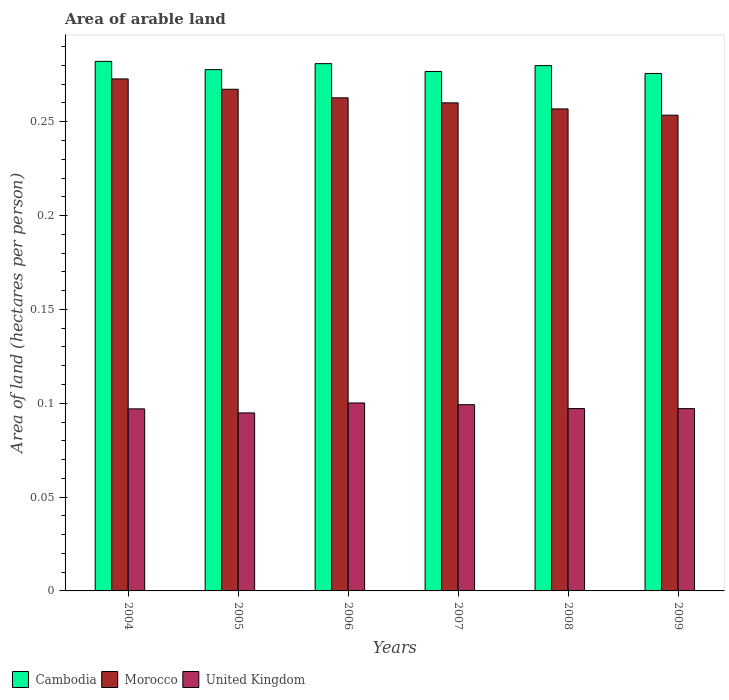How many groups of bars are there?
Provide a short and direct response. 6. Are the number of bars on each tick of the X-axis equal?
Offer a very short reply. Yes. How many bars are there on the 5th tick from the right?
Make the answer very short. 3. In how many cases, is the number of bars for a given year not equal to the number of legend labels?
Offer a very short reply. 0. What is the total arable land in Morocco in 2005?
Provide a short and direct response. 0.27. Across all years, what is the maximum total arable land in United Kingdom?
Keep it short and to the point. 0.1. Across all years, what is the minimum total arable land in United Kingdom?
Provide a short and direct response. 0.09. In which year was the total arable land in Cambodia maximum?
Your response must be concise. 2004. What is the total total arable land in Morocco in the graph?
Provide a succinct answer. 1.57. What is the difference between the total arable land in Morocco in 2008 and that in 2009?
Provide a short and direct response. 0. What is the difference between the total arable land in Cambodia in 2009 and the total arable land in United Kingdom in 2006?
Provide a short and direct response. 0.18. What is the average total arable land in United Kingdom per year?
Make the answer very short. 0.1. In the year 2007, what is the difference between the total arable land in United Kingdom and total arable land in Cambodia?
Your response must be concise. -0.18. What is the ratio of the total arable land in United Kingdom in 2008 to that in 2009?
Your answer should be compact. 1. Is the difference between the total arable land in United Kingdom in 2006 and 2007 greater than the difference between the total arable land in Cambodia in 2006 and 2007?
Provide a succinct answer. No. What is the difference between the highest and the second highest total arable land in Cambodia?
Provide a short and direct response. 0. What is the difference between the highest and the lowest total arable land in United Kingdom?
Your response must be concise. 0.01. In how many years, is the total arable land in Morocco greater than the average total arable land in Morocco taken over all years?
Provide a short and direct response. 3. What does the 1st bar from the left in 2008 represents?
Provide a succinct answer. Cambodia. What does the 3rd bar from the right in 2004 represents?
Make the answer very short. Cambodia. Is it the case that in every year, the sum of the total arable land in Morocco and total arable land in United Kingdom is greater than the total arable land in Cambodia?
Keep it short and to the point. Yes. Are the values on the major ticks of Y-axis written in scientific E-notation?
Ensure brevity in your answer.  No. Does the graph contain any zero values?
Make the answer very short. No. Does the graph contain grids?
Your answer should be compact. No. How many legend labels are there?
Provide a succinct answer. 3. What is the title of the graph?
Give a very brief answer. Area of arable land. Does "Malawi" appear as one of the legend labels in the graph?
Provide a succinct answer. No. What is the label or title of the X-axis?
Give a very brief answer. Years. What is the label or title of the Y-axis?
Offer a very short reply. Area of land (hectares per person). What is the Area of land (hectares per person) of Cambodia in 2004?
Keep it short and to the point. 0.28. What is the Area of land (hectares per person) of Morocco in 2004?
Provide a short and direct response. 0.27. What is the Area of land (hectares per person) in United Kingdom in 2004?
Your response must be concise. 0.1. What is the Area of land (hectares per person) of Cambodia in 2005?
Offer a very short reply. 0.28. What is the Area of land (hectares per person) of Morocco in 2005?
Give a very brief answer. 0.27. What is the Area of land (hectares per person) in United Kingdom in 2005?
Ensure brevity in your answer.  0.09. What is the Area of land (hectares per person) of Cambodia in 2006?
Provide a short and direct response. 0.28. What is the Area of land (hectares per person) in Morocco in 2006?
Your answer should be compact. 0.26. What is the Area of land (hectares per person) in United Kingdom in 2006?
Ensure brevity in your answer.  0.1. What is the Area of land (hectares per person) of Cambodia in 2007?
Provide a short and direct response. 0.28. What is the Area of land (hectares per person) in Morocco in 2007?
Keep it short and to the point. 0.26. What is the Area of land (hectares per person) in United Kingdom in 2007?
Keep it short and to the point. 0.1. What is the Area of land (hectares per person) in Cambodia in 2008?
Provide a succinct answer. 0.28. What is the Area of land (hectares per person) in Morocco in 2008?
Offer a very short reply. 0.26. What is the Area of land (hectares per person) in United Kingdom in 2008?
Keep it short and to the point. 0.1. What is the Area of land (hectares per person) in Cambodia in 2009?
Offer a very short reply. 0.28. What is the Area of land (hectares per person) of Morocco in 2009?
Provide a succinct answer. 0.25. What is the Area of land (hectares per person) of United Kingdom in 2009?
Your answer should be compact. 0.1. Across all years, what is the maximum Area of land (hectares per person) in Cambodia?
Offer a very short reply. 0.28. Across all years, what is the maximum Area of land (hectares per person) of Morocco?
Offer a terse response. 0.27. Across all years, what is the maximum Area of land (hectares per person) of United Kingdom?
Ensure brevity in your answer.  0.1. Across all years, what is the minimum Area of land (hectares per person) in Cambodia?
Keep it short and to the point. 0.28. Across all years, what is the minimum Area of land (hectares per person) of Morocco?
Keep it short and to the point. 0.25. Across all years, what is the minimum Area of land (hectares per person) in United Kingdom?
Your response must be concise. 0.09. What is the total Area of land (hectares per person) of Cambodia in the graph?
Your response must be concise. 1.67. What is the total Area of land (hectares per person) of Morocco in the graph?
Keep it short and to the point. 1.57. What is the total Area of land (hectares per person) of United Kingdom in the graph?
Your answer should be compact. 0.59. What is the difference between the Area of land (hectares per person) of Cambodia in 2004 and that in 2005?
Make the answer very short. 0. What is the difference between the Area of land (hectares per person) of Morocco in 2004 and that in 2005?
Ensure brevity in your answer.  0.01. What is the difference between the Area of land (hectares per person) of United Kingdom in 2004 and that in 2005?
Give a very brief answer. 0. What is the difference between the Area of land (hectares per person) in Cambodia in 2004 and that in 2006?
Your answer should be very brief. 0. What is the difference between the Area of land (hectares per person) in Morocco in 2004 and that in 2006?
Provide a succinct answer. 0.01. What is the difference between the Area of land (hectares per person) of United Kingdom in 2004 and that in 2006?
Provide a short and direct response. -0. What is the difference between the Area of land (hectares per person) in Cambodia in 2004 and that in 2007?
Keep it short and to the point. 0.01. What is the difference between the Area of land (hectares per person) of Morocco in 2004 and that in 2007?
Your answer should be very brief. 0.01. What is the difference between the Area of land (hectares per person) in United Kingdom in 2004 and that in 2007?
Keep it short and to the point. -0. What is the difference between the Area of land (hectares per person) in Cambodia in 2004 and that in 2008?
Offer a very short reply. 0. What is the difference between the Area of land (hectares per person) of Morocco in 2004 and that in 2008?
Provide a succinct answer. 0.02. What is the difference between the Area of land (hectares per person) of United Kingdom in 2004 and that in 2008?
Ensure brevity in your answer.  -0. What is the difference between the Area of land (hectares per person) in Cambodia in 2004 and that in 2009?
Keep it short and to the point. 0.01. What is the difference between the Area of land (hectares per person) in Morocco in 2004 and that in 2009?
Keep it short and to the point. 0.02. What is the difference between the Area of land (hectares per person) in United Kingdom in 2004 and that in 2009?
Ensure brevity in your answer.  -0. What is the difference between the Area of land (hectares per person) in Cambodia in 2005 and that in 2006?
Make the answer very short. -0. What is the difference between the Area of land (hectares per person) in Morocco in 2005 and that in 2006?
Ensure brevity in your answer.  0. What is the difference between the Area of land (hectares per person) in United Kingdom in 2005 and that in 2006?
Make the answer very short. -0.01. What is the difference between the Area of land (hectares per person) of Cambodia in 2005 and that in 2007?
Give a very brief answer. 0. What is the difference between the Area of land (hectares per person) of Morocco in 2005 and that in 2007?
Your answer should be compact. 0.01. What is the difference between the Area of land (hectares per person) of United Kingdom in 2005 and that in 2007?
Offer a very short reply. -0. What is the difference between the Area of land (hectares per person) of Cambodia in 2005 and that in 2008?
Provide a short and direct response. -0. What is the difference between the Area of land (hectares per person) in Morocco in 2005 and that in 2008?
Make the answer very short. 0.01. What is the difference between the Area of land (hectares per person) in United Kingdom in 2005 and that in 2008?
Provide a succinct answer. -0. What is the difference between the Area of land (hectares per person) of Cambodia in 2005 and that in 2009?
Your answer should be compact. 0. What is the difference between the Area of land (hectares per person) in Morocco in 2005 and that in 2009?
Keep it short and to the point. 0.01. What is the difference between the Area of land (hectares per person) in United Kingdom in 2005 and that in 2009?
Your answer should be very brief. -0. What is the difference between the Area of land (hectares per person) in Cambodia in 2006 and that in 2007?
Provide a short and direct response. 0. What is the difference between the Area of land (hectares per person) of Morocco in 2006 and that in 2007?
Offer a terse response. 0. What is the difference between the Area of land (hectares per person) of United Kingdom in 2006 and that in 2007?
Keep it short and to the point. 0. What is the difference between the Area of land (hectares per person) of Cambodia in 2006 and that in 2008?
Provide a succinct answer. 0. What is the difference between the Area of land (hectares per person) in Morocco in 2006 and that in 2008?
Offer a terse response. 0.01. What is the difference between the Area of land (hectares per person) of United Kingdom in 2006 and that in 2008?
Make the answer very short. 0. What is the difference between the Area of land (hectares per person) of Cambodia in 2006 and that in 2009?
Provide a short and direct response. 0.01. What is the difference between the Area of land (hectares per person) of Morocco in 2006 and that in 2009?
Your answer should be very brief. 0.01. What is the difference between the Area of land (hectares per person) in United Kingdom in 2006 and that in 2009?
Keep it short and to the point. 0. What is the difference between the Area of land (hectares per person) in Cambodia in 2007 and that in 2008?
Offer a very short reply. -0. What is the difference between the Area of land (hectares per person) of Morocco in 2007 and that in 2008?
Make the answer very short. 0. What is the difference between the Area of land (hectares per person) in United Kingdom in 2007 and that in 2008?
Give a very brief answer. 0. What is the difference between the Area of land (hectares per person) in Cambodia in 2007 and that in 2009?
Give a very brief answer. 0. What is the difference between the Area of land (hectares per person) of Morocco in 2007 and that in 2009?
Offer a terse response. 0.01. What is the difference between the Area of land (hectares per person) of United Kingdom in 2007 and that in 2009?
Give a very brief answer. 0. What is the difference between the Area of land (hectares per person) of Cambodia in 2008 and that in 2009?
Your response must be concise. 0. What is the difference between the Area of land (hectares per person) in Morocco in 2008 and that in 2009?
Provide a short and direct response. 0. What is the difference between the Area of land (hectares per person) of United Kingdom in 2008 and that in 2009?
Keep it short and to the point. 0. What is the difference between the Area of land (hectares per person) of Cambodia in 2004 and the Area of land (hectares per person) of Morocco in 2005?
Offer a terse response. 0.01. What is the difference between the Area of land (hectares per person) of Cambodia in 2004 and the Area of land (hectares per person) of United Kingdom in 2005?
Give a very brief answer. 0.19. What is the difference between the Area of land (hectares per person) in Morocco in 2004 and the Area of land (hectares per person) in United Kingdom in 2005?
Keep it short and to the point. 0.18. What is the difference between the Area of land (hectares per person) of Cambodia in 2004 and the Area of land (hectares per person) of Morocco in 2006?
Make the answer very short. 0.02. What is the difference between the Area of land (hectares per person) in Cambodia in 2004 and the Area of land (hectares per person) in United Kingdom in 2006?
Your answer should be very brief. 0.18. What is the difference between the Area of land (hectares per person) of Morocco in 2004 and the Area of land (hectares per person) of United Kingdom in 2006?
Provide a short and direct response. 0.17. What is the difference between the Area of land (hectares per person) of Cambodia in 2004 and the Area of land (hectares per person) of Morocco in 2007?
Your answer should be compact. 0.02. What is the difference between the Area of land (hectares per person) of Cambodia in 2004 and the Area of land (hectares per person) of United Kingdom in 2007?
Provide a short and direct response. 0.18. What is the difference between the Area of land (hectares per person) of Morocco in 2004 and the Area of land (hectares per person) of United Kingdom in 2007?
Your answer should be very brief. 0.17. What is the difference between the Area of land (hectares per person) in Cambodia in 2004 and the Area of land (hectares per person) in Morocco in 2008?
Provide a short and direct response. 0.03. What is the difference between the Area of land (hectares per person) in Cambodia in 2004 and the Area of land (hectares per person) in United Kingdom in 2008?
Your response must be concise. 0.18. What is the difference between the Area of land (hectares per person) in Morocco in 2004 and the Area of land (hectares per person) in United Kingdom in 2008?
Your response must be concise. 0.18. What is the difference between the Area of land (hectares per person) in Cambodia in 2004 and the Area of land (hectares per person) in Morocco in 2009?
Your response must be concise. 0.03. What is the difference between the Area of land (hectares per person) in Cambodia in 2004 and the Area of land (hectares per person) in United Kingdom in 2009?
Your answer should be very brief. 0.18. What is the difference between the Area of land (hectares per person) of Morocco in 2004 and the Area of land (hectares per person) of United Kingdom in 2009?
Make the answer very short. 0.18. What is the difference between the Area of land (hectares per person) in Cambodia in 2005 and the Area of land (hectares per person) in Morocco in 2006?
Your answer should be compact. 0.01. What is the difference between the Area of land (hectares per person) of Cambodia in 2005 and the Area of land (hectares per person) of United Kingdom in 2006?
Keep it short and to the point. 0.18. What is the difference between the Area of land (hectares per person) of Morocco in 2005 and the Area of land (hectares per person) of United Kingdom in 2006?
Give a very brief answer. 0.17. What is the difference between the Area of land (hectares per person) of Cambodia in 2005 and the Area of land (hectares per person) of Morocco in 2007?
Make the answer very short. 0.02. What is the difference between the Area of land (hectares per person) of Cambodia in 2005 and the Area of land (hectares per person) of United Kingdom in 2007?
Give a very brief answer. 0.18. What is the difference between the Area of land (hectares per person) in Morocco in 2005 and the Area of land (hectares per person) in United Kingdom in 2007?
Provide a succinct answer. 0.17. What is the difference between the Area of land (hectares per person) of Cambodia in 2005 and the Area of land (hectares per person) of Morocco in 2008?
Keep it short and to the point. 0.02. What is the difference between the Area of land (hectares per person) of Cambodia in 2005 and the Area of land (hectares per person) of United Kingdom in 2008?
Ensure brevity in your answer.  0.18. What is the difference between the Area of land (hectares per person) in Morocco in 2005 and the Area of land (hectares per person) in United Kingdom in 2008?
Offer a very short reply. 0.17. What is the difference between the Area of land (hectares per person) in Cambodia in 2005 and the Area of land (hectares per person) in Morocco in 2009?
Your response must be concise. 0.02. What is the difference between the Area of land (hectares per person) in Cambodia in 2005 and the Area of land (hectares per person) in United Kingdom in 2009?
Your response must be concise. 0.18. What is the difference between the Area of land (hectares per person) in Morocco in 2005 and the Area of land (hectares per person) in United Kingdom in 2009?
Ensure brevity in your answer.  0.17. What is the difference between the Area of land (hectares per person) in Cambodia in 2006 and the Area of land (hectares per person) in Morocco in 2007?
Provide a succinct answer. 0.02. What is the difference between the Area of land (hectares per person) of Cambodia in 2006 and the Area of land (hectares per person) of United Kingdom in 2007?
Keep it short and to the point. 0.18. What is the difference between the Area of land (hectares per person) in Morocco in 2006 and the Area of land (hectares per person) in United Kingdom in 2007?
Give a very brief answer. 0.16. What is the difference between the Area of land (hectares per person) of Cambodia in 2006 and the Area of land (hectares per person) of Morocco in 2008?
Offer a terse response. 0.02. What is the difference between the Area of land (hectares per person) in Cambodia in 2006 and the Area of land (hectares per person) in United Kingdom in 2008?
Keep it short and to the point. 0.18. What is the difference between the Area of land (hectares per person) in Morocco in 2006 and the Area of land (hectares per person) in United Kingdom in 2008?
Make the answer very short. 0.17. What is the difference between the Area of land (hectares per person) of Cambodia in 2006 and the Area of land (hectares per person) of Morocco in 2009?
Your response must be concise. 0.03. What is the difference between the Area of land (hectares per person) in Cambodia in 2006 and the Area of land (hectares per person) in United Kingdom in 2009?
Provide a short and direct response. 0.18. What is the difference between the Area of land (hectares per person) in Morocco in 2006 and the Area of land (hectares per person) in United Kingdom in 2009?
Provide a succinct answer. 0.17. What is the difference between the Area of land (hectares per person) in Cambodia in 2007 and the Area of land (hectares per person) in United Kingdom in 2008?
Ensure brevity in your answer.  0.18. What is the difference between the Area of land (hectares per person) in Morocco in 2007 and the Area of land (hectares per person) in United Kingdom in 2008?
Your answer should be very brief. 0.16. What is the difference between the Area of land (hectares per person) in Cambodia in 2007 and the Area of land (hectares per person) in Morocco in 2009?
Keep it short and to the point. 0.02. What is the difference between the Area of land (hectares per person) in Cambodia in 2007 and the Area of land (hectares per person) in United Kingdom in 2009?
Provide a succinct answer. 0.18. What is the difference between the Area of land (hectares per person) of Morocco in 2007 and the Area of land (hectares per person) of United Kingdom in 2009?
Your answer should be compact. 0.16. What is the difference between the Area of land (hectares per person) of Cambodia in 2008 and the Area of land (hectares per person) of Morocco in 2009?
Ensure brevity in your answer.  0.03. What is the difference between the Area of land (hectares per person) of Cambodia in 2008 and the Area of land (hectares per person) of United Kingdom in 2009?
Your answer should be very brief. 0.18. What is the difference between the Area of land (hectares per person) of Morocco in 2008 and the Area of land (hectares per person) of United Kingdom in 2009?
Provide a short and direct response. 0.16. What is the average Area of land (hectares per person) in Cambodia per year?
Give a very brief answer. 0.28. What is the average Area of land (hectares per person) of Morocco per year?
Your answer should be very brief. 0.26. What is the average Area of land (hectares per person) of United Kingdom per year?
Your answer should be compact. 0.1. In the year 2004, what is the difference between the Area of land (hectares per person) of Cambodia and Area of land (hectares per person) of Morocco?
Give a very brief answer. 0.01. In the year 2004, what is the difference between the Area of land (hectares per person) of Cambodia and Area of land (hectares per person) of United Kingdom?
Your response must be concise. 0.19. In the year 2004, what is the difference between the Area of land (hectares per person) of Morocco and Area of land (hectares per person) of United Kingdom?
Provide a short and direct response. 0.18. In the year 2005, what is the difference between the Area of land (hectares per person) in Cambodia and Area of land (hectares per person) in Morocco?
Offer a terse response. 0.01. In the year 2005, what is the difference between the Area of land (hectares per person) of Cambodia and Area of land (hectares per person) of United Kingdom?
Your answer should be very brief. 0.18. In the year 2005, what is the difference between the Area of land (hectares per person) of Morocco and Area of land (hectares per person) of United Kingdom?
Your answer should be very brief. 0.17. In the year 2006, what is the difference between the Area of land (hectares per person) of Cambodia and Area of land (hectares per person) of Morocco?
Your response must be concise. 0.02. In the year 2006, what is the difference between the Area of land (hectares per person) in Cambodia and Area of land (hectares per person) in United Kingdom?
Your answer should be very brief. 0.18. In the year 2006, what is the difference between the Area of land (hectares per person) in Morocco and Area of land (hectares per person) in United Kingdom?
Offer a very short reply. 0.16. In the year 2007, what is the difference between the Area of land (hectares per person) of Cambodia and Area of land (hectares per person) of Morocco?
Your response must be concise. 0.02. In the year 2007, what is the difference between the Area of land (hectares per person) in Cambodia and Area of land (hectares per person) in United Kingdom?
Give a very brief answer. 0.18. In the year 2007, what is the difference between the Area of land (hectares per person) in Morocco and Area of land (hectares per person) in United Kingdom?
Make the answer very short. 0.16. In the year 2008, what is the difference between the Area of land (hectares per person) of Cambodia and Area of land (hectares per person) of Morocco?
Your answer should be very brief. 0.02. In the year 2008, what is the difference between the Area of land (hectares per person) in Cambodia and Area of land (hectares per person) in United Kingdom?
Keep it short and to the point. 0.18. In the year 2008, what is the difference between the Area of land (hectares per person) of Morocco and Area of land (hectares per person) of United Kingdom?
Ensure brevity in your answer.  0.16. In the year 2009, what is the difference between the Area of land (hectares per person) of Cambodia and Area of land (hectares per person) of Morocco?
Your answer should be compact. 0.02. In the year 2009, what is the difference between the Area of land (hectares per person) of Cambodia and Area of land (hectares per person) of United Kingdom?
Your answer should be very brief. 0.18. In the year 2009, what is the difference between the Area of land (hectares per person) of Morocco and Area of land (hectares per person) of United Kingdom?
Your answer should be compact. 0.16. What is the ratio of the Area of land (hectares per person) in Cambodia in 2004 to that in 2005?
Provide a short and direct response. 1.02. What is the ratio of the Area of land (hectares per person) in Morocco in 2004 to that in 2005?
Your answer should be very brief. 1.02. What is the ratio of the Area of land (hectares per person) of United Kingdom in 2004 to that in 2005?
Offer a very short reply. 1.02. What is the ratio of the Area of land (hectares per person) in Cambodia in 2004 to that in 2006?
Your answer should be compact. 1. What is the ratio of the Area of land (hectares per person) in Morocco in 2004 to that in 2006?
Your answer should be very brief. 1.04. What is the ratio of the Area of land (hectares per person) of United Kingdom in 2004 to that in 2006?
Offer a very short reply. 0.97. What is the ratio of the Area of land (hectares per person) of Cambodia in 2004 to that in 2007?
Provide a short and direct response. 1.02. What is the ratio of the Area of land (hectares per person) in Morocco in 2004 to that in 2007?
Your response must be concise. 1.05. What is the ratio of the Area of land (hectares per person) in United Kingdom in 2004 to that in 2007?
Provide a succinct answer. 0.98. What is the ratio of the Area of land (hectares per person) of Morocco in 2004 to that in 2008?
Keep it short and to the point. 1.06. What is the ratio of the Area of land (hectares per person) in Cambodia in 2004 to that in 2009?
Your answer should be very brief. 1.02. What is the ratio of the Area of land (hectares per person) in Morocco in 2004 to that in 2009?
Your response must be concise. 1.08. What is the ratio of the Area of land (hectares per person) of United Kingdom in 2004 to that in 2009?
Offer a terse response. 1. What is the ratio of the Area of land (hectares per person) of Cambodia in 2005 to that in 2006?
Your answer should be very brief. 0.99. What is the ratio of the Area of land (hectares per person) of Morocco in 2005 to that in 2006?
Keep it short and to the point. 1.02. What is the ratio of the Area of land (hectares per person) of United Kingdom in 2005 to that in 2006?
Your response must be concise. 0.95. What is the ratio of the Area of land (hectares per person) of Morocco in 2005 to that in 2007?
Provide a short and direct response. 1.03. What is the ratio of the Area of land (hectares per person) in United Kingdom in 2005 to that in 2007?
Your answer should be compact. 0.96. What is the ratio of the Area of land (hectares per person) in Morocco in 2005 to that in 2008?
Your answer should be compact. 1.04. What is the ratio of the Area of land (hectares per person) of United Kingdom in 2005 to that in 2008?
Make the answer very short. 0.98. What is the ratio of the Area of land (hectares per person) in Cambodia in 2005 to that in 2009?
Offer a terse response. 1.01. What is the ratio of the Area of land (hectares per person) in Morocco in 2005 to that in 2009?
Offer a very short reply. 1.05. What is the ratio of the Area of land (hectares per person) of United Kingdom in 2005 to that in 2009?
Provide a short and direct response. 0.98. What is the ratio of the Area of land (hectares per person) of Morocco in 2006 to that in 2007?
Your answer should be compact. 1.01. What is the ratio of the Area of land (hectares per person) of United Kingdom in 2006 to that in 2007?
Offer a terse response. 1.01. What is the ratio of the Area of land (hectares per person) of Cambodia in 2006 to that in 2008?
Your answer should be compact. 1. What is the ratio of the Area of land (hectares per person) of Morocco in 2006 to that in 2008?
Offer a very short reply. 1.02. What is the ratio of the Area of land (hectares per person) of United Kingdom in 2006 to that in 2008?
Keep it short and to the point. 1.03. What is the ratio of the Area of land (hectares per person) in Cambodia in 2006 to that in 2009?
Make the answer very short. 1.02. What is the ratio of the Area of land (hectares per person) in Morocco in 2006 to that in 2009?
Provide a short and direct response. 1.04. What is the ratio of the Area of land (hectares per person) in United Kingdom in 2006 to that in 2009?
Ensure brevity in your answer.  1.03. What is the ratio of the Area of land (hectares per person) in Cambodia in 2007 to that in 2008?
Your response must be concise. 0.99. What is the ratio of the Area of land (hectares per person) in Morocco in 2007 to that in 2008?
Offer a terse response. 1.01. What is the ratio of the Area of land (hectares per person) of United Kingdom in 2007 to that in 2008?
Provide a short and direct response. 1.02. What is the ratio of the Area of land (hectares per person) of Morocco in 2007 to that in 2009?
Ensure brevity in your answer.  1.03. What is the ratio of the Area of land (hectares per person) of United Kingdom in 2007 to that in 2009?
Your answer should be compact. 1.02. What is the ratio of the Area of land (hectares per person) in Cambodia in 2008 to that in 2009?
Your answer should be compact. 1.02. What is the ratio of the Area of land (hectares per person) of Morocco in 2008 to that in 2009?
Ensure brevity in your answer.  1.01. What is the difference between the highest and the second highest Area of land (hectares per person) in Cambodia?
Ensure brevity in your answer.  0. What is the difference between the highest and the second highest Area of land (hectares per person) of Morocco?
Provide a short and direct response. 0.01. What is the difference between the highest and the second highest Area of land (hectares per person) in United Kingdom?
Your response must be concise. 0. What is the difference between the highest and the lowest Area of land (hectares per person) of Cambodia?
Ensure brevity in your answer.  0.01. What is the difference between the highest and the lowest Area of land (hectares per person) in Morocco?
Provide a succinct answer. 0.02. What is the difference between the highest and the lowest Area of land (hectares per person) in United Kingdom?
Ensure brevity in your answer.  0.01. 